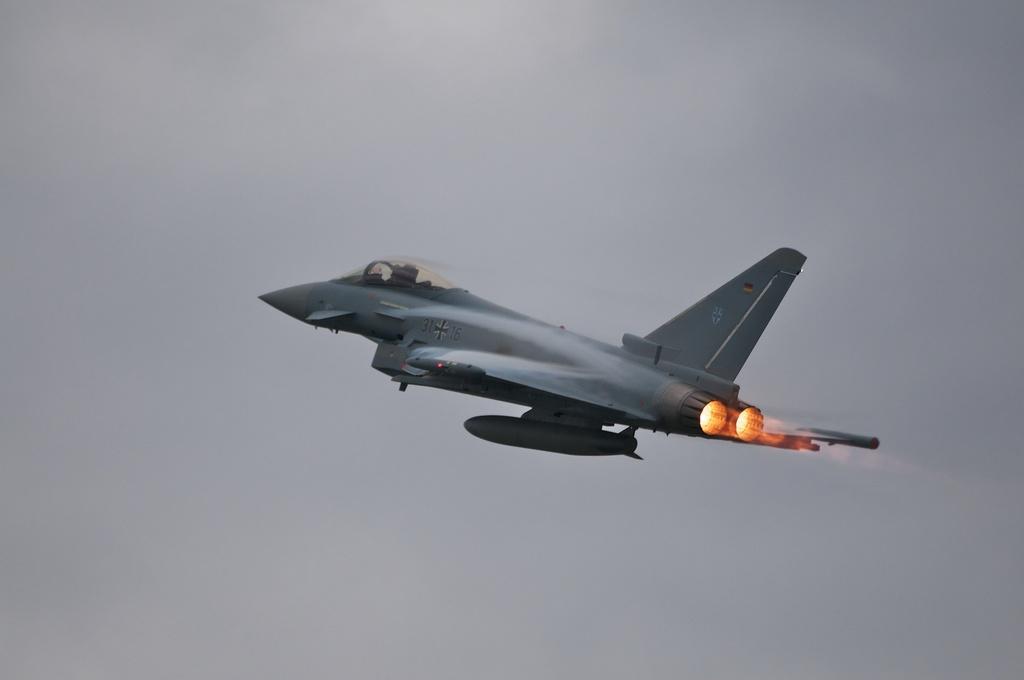Describe this image in one or two sentences. This image consists of a plane. In the background, there is a sky. And there is a fire. 